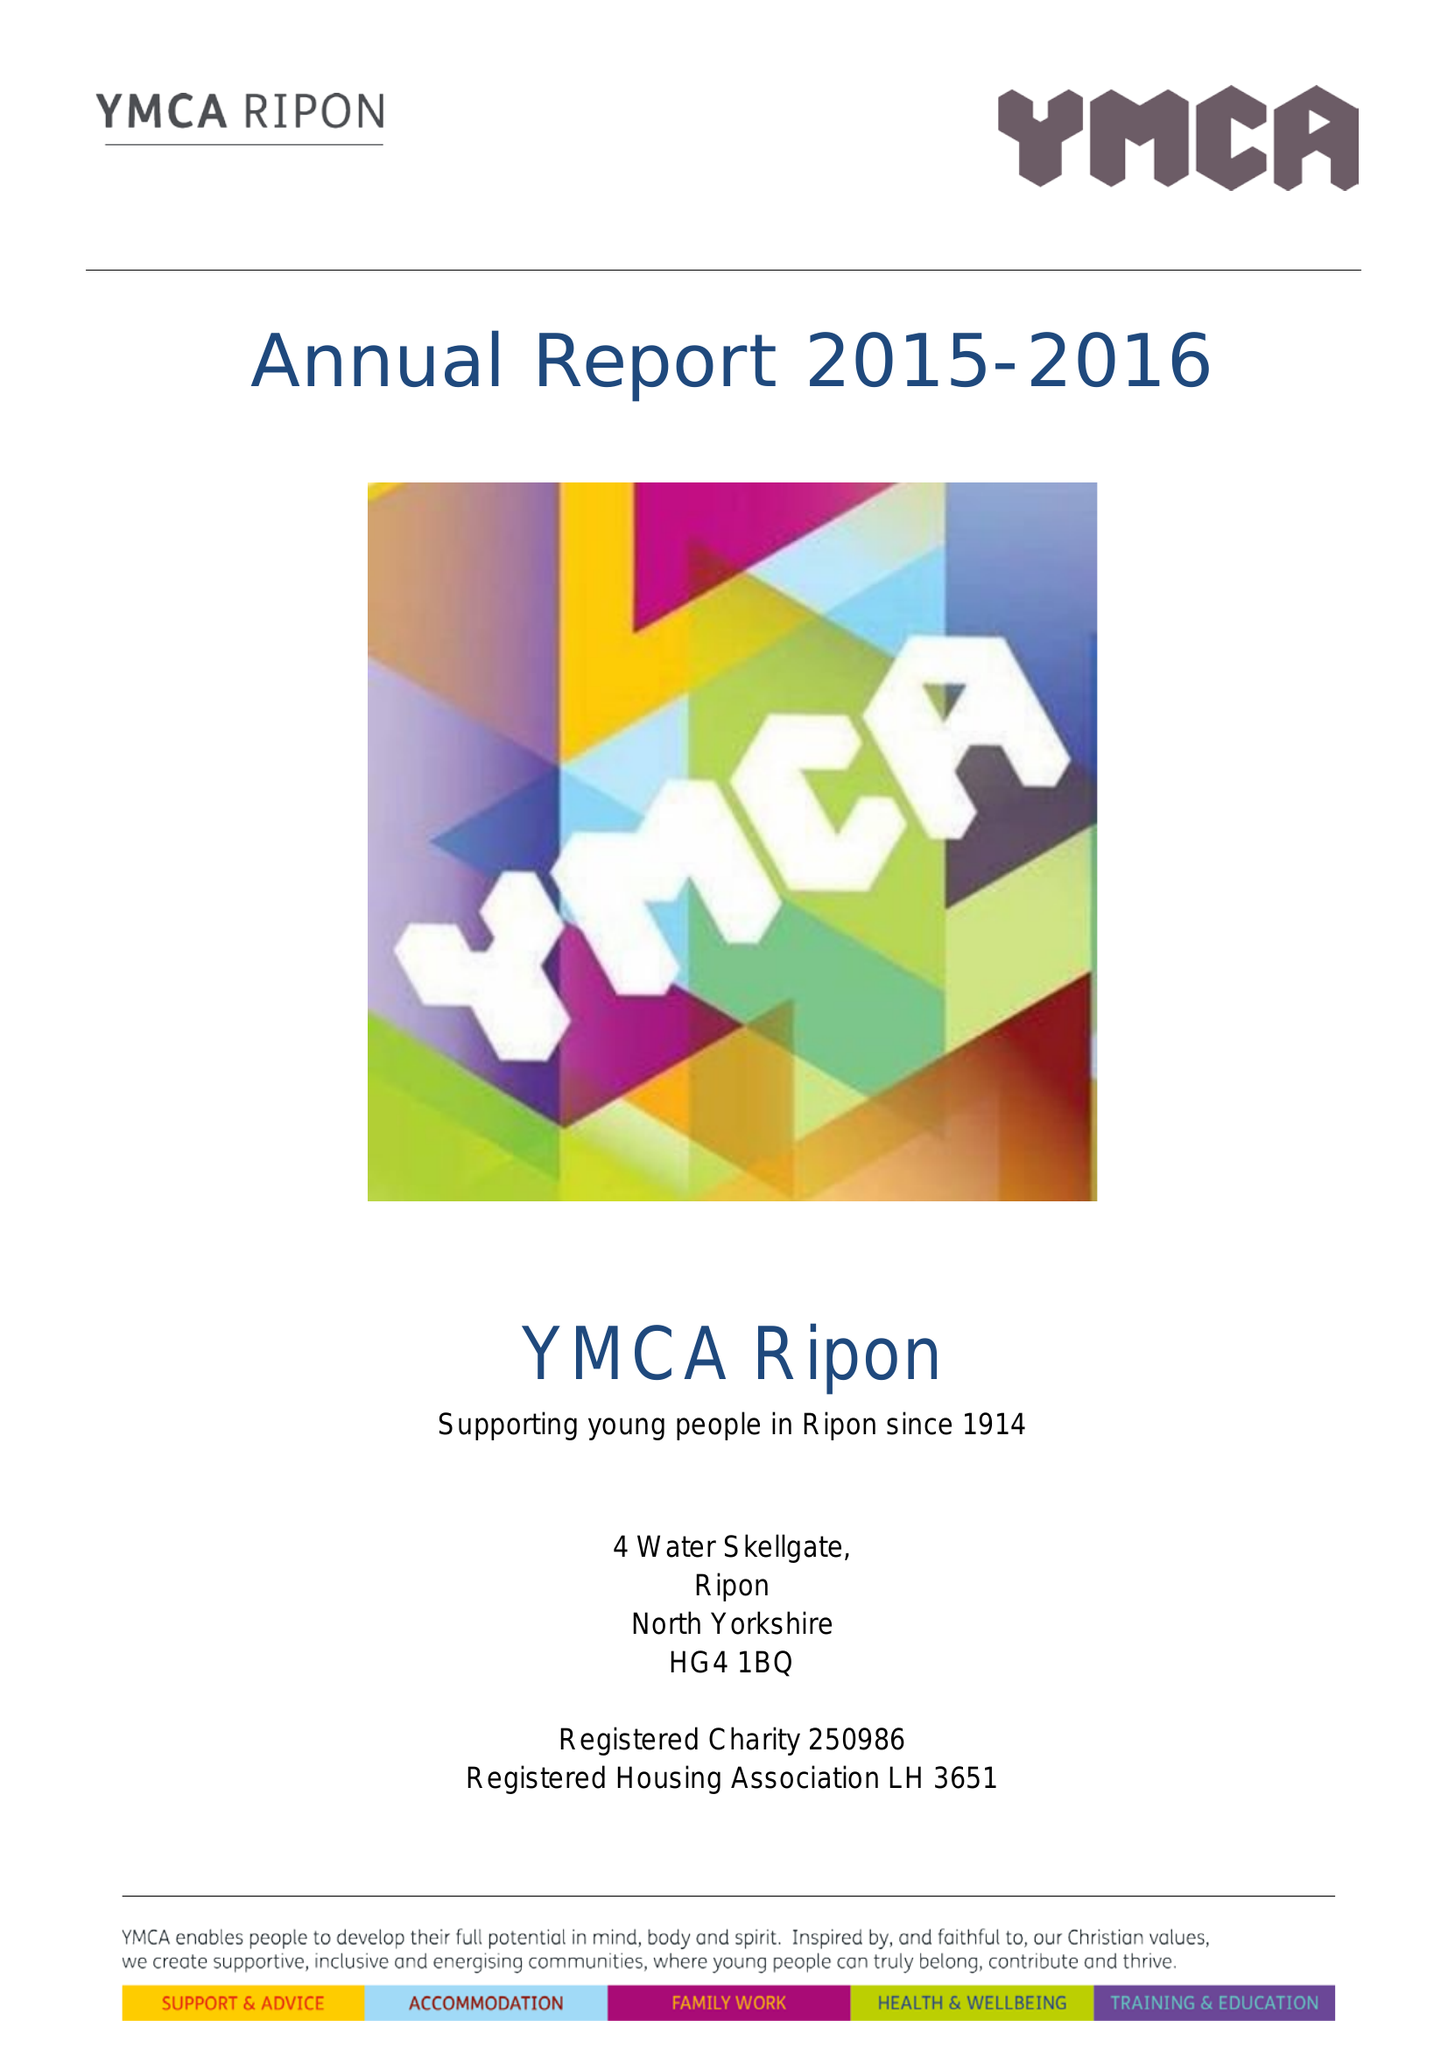What is the value for the address__post_town?
Answer the question using a single word or phrase. RIPON 